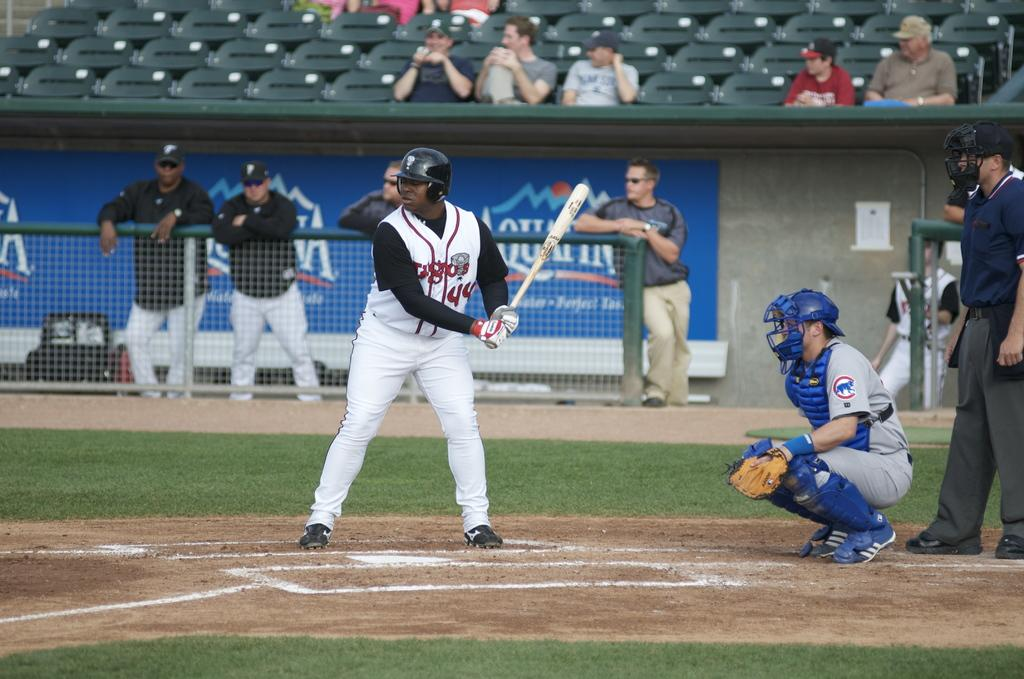<image>
Describe the image concisely. Player number 44 stands at the batter's box getting ready to swing. 